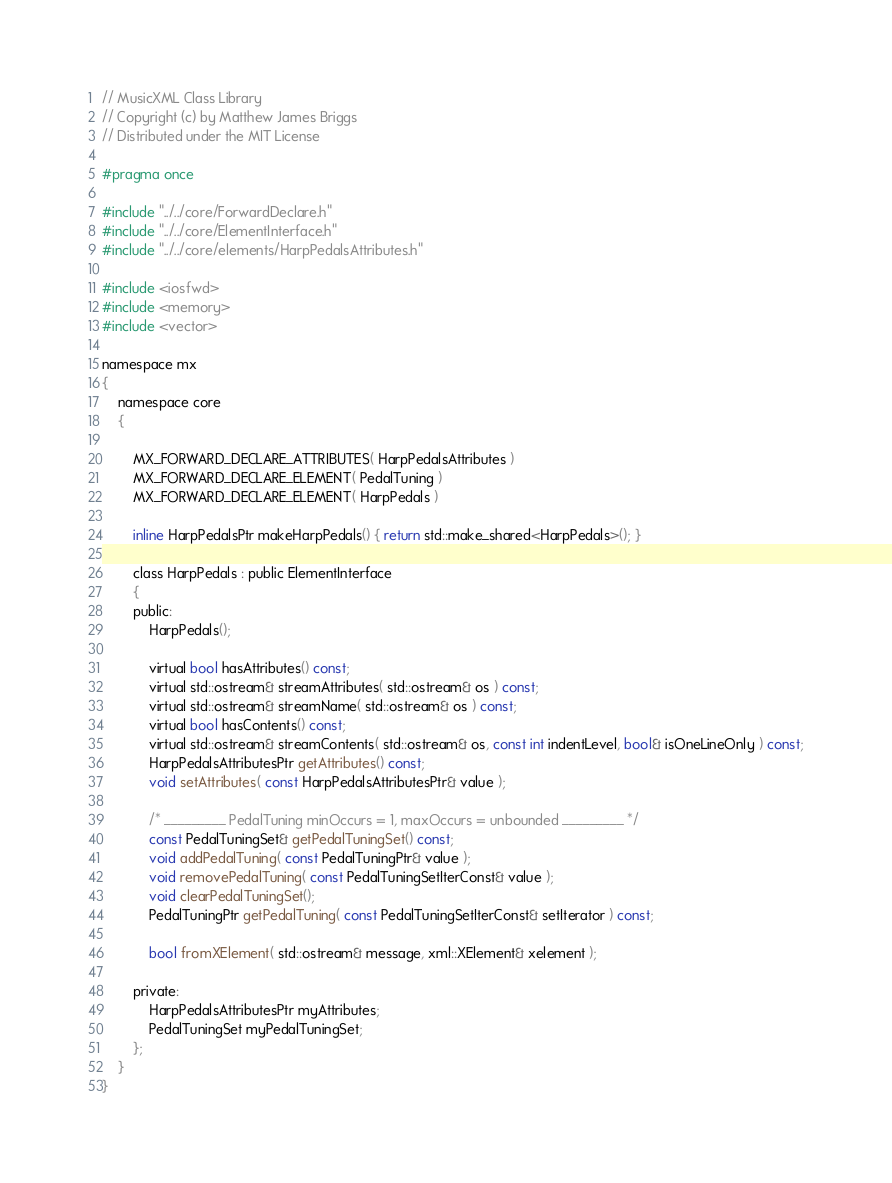<code> <loc_0><loc_0><loc_500><loc_500><_C_>// MusicXML Class Library
// Copyright (c) by Matthew James Briggs
// Distributed under the MIT License

#pragma once

#include "../../core/ForwardDeclare.h"
#include "../../core/ElementInterface.h"
#include "../../core/elements/HarpPedalsAttributes.h"

#include <iosfwd>
#include <memory>
#include <vector>

namespace mx
{
    namespace core
    {

        MX_FORWARD_DECLARE_ATTRIBUTES( HarpPedalsAttributes )
        MX_FORWARD_DECLARE_ELEMENT( PedalTuning )
        MX_FORWARD_DECLARE_ELEMENT( HarpPedals )

        inline HarpPedalsPtr makeHarpPedals() { return std::make_shared<HarpPedals>(); }

        class HarpPedals : public ElementInterface
        {
        public:
            HarpPedals();

            virtual bool hasAttributes() const;
            virtual std::ostream& streamAttributes( std::ostream& os ) const;
            virtual std::ostream& streamName( std::ostream& os ) const;
            virtual bool hasContents() const;
            virtual std::ostream& streamContents( std::ostream& os, const int indentLevel, bool& isOneLineOnly ) const;
            HarpPedalsAttributesPtr getAttributes() const;
            void setAttributes( const HarpPedalsAttributesPtr& value );

            /* _________ PedalTuning minOccurs = 1, maxOccurs = unbounded _________ */
            const PedalTuningSet& getPedalTuningSet() const;
            void addPedalTuning( const PedalTuningPtr& value );
            void removePedalTuning( const PedalTuningSetIterConst& value );
            void clearPedalTuningSet();
            PedalTuningPtr getPedalTuning( const PedalTuningSetIterConst& setIterator ) const;

            bool fromXElement( std::ostream& message, xml::XElement& xelement );

        private:
            HarpPedalsAttributesPtr myAttributes;
            PedalTuningSet myPedalTuningSet;
        };
    }
}
</code> 